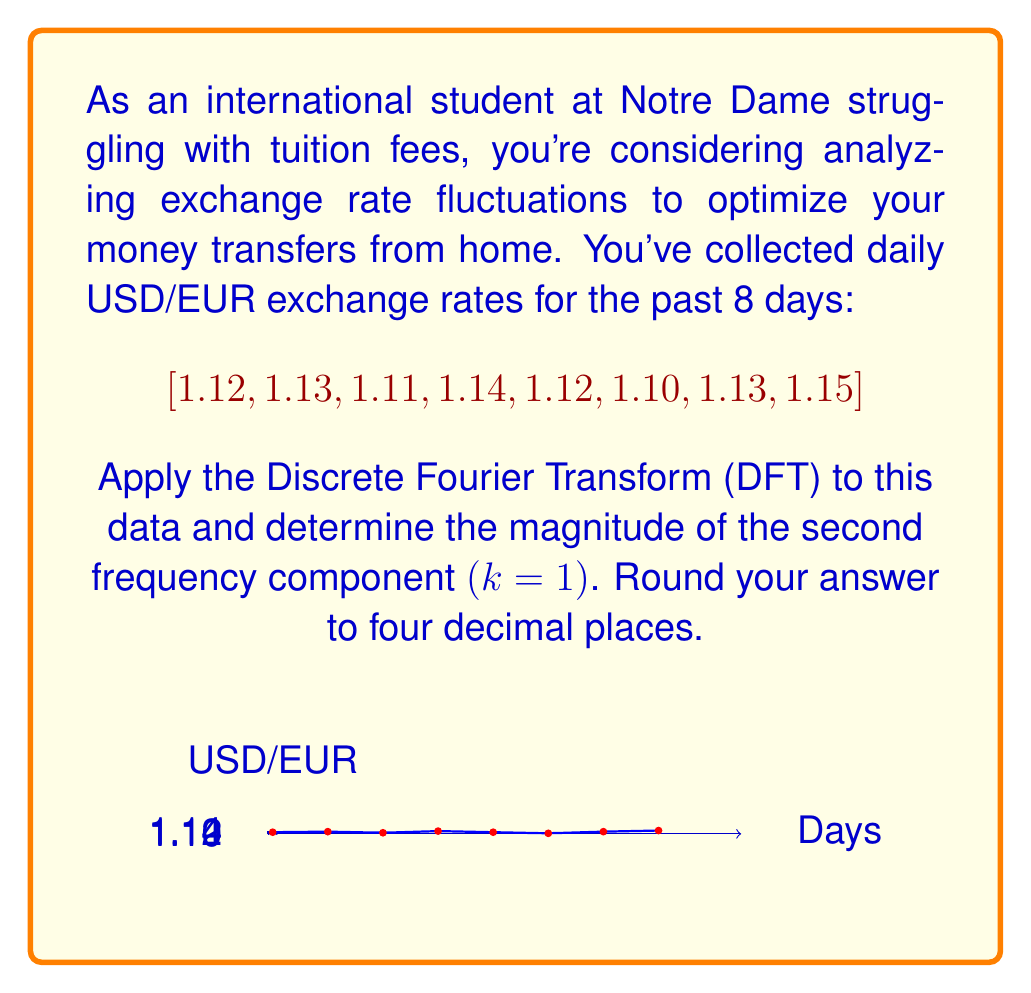What is the answer to this math problem? Let's approach this step-by-step:

1) The Discrete Fourier Transform (DFT) is given by:

   $$X[k] = \sum_{n=0}^{N-1} x[n] e^{-i2\pi kn/N}$$

   where $N$ is the number of samples (8 in this case), $k$ is the frequency index, and $x[n]$ are the input samples.

2) We need to calculate $X[1]$, as we're interested in the second frequency component (k=1):

   $$X[1] = \sum_{n=0}^{7} x[n] e^{-i2\pi n/8}$$

3) Let's expand this:

   $$X[1] = 1.12e^{-i2\pi(0)/8} + 1.13e^{-i2\pi(1)/8} + 1.11e^{-i2\pi(2)/8} + 1.14e^{-i2\pi(3)/8} + 1.12e^{-i2\pi(4)/8} + 1.10e^{-i2\pi(5)/8} + 1.13e^{-i2\pi(6)/8} + 1.15e^{-i2\pi(7)/8}$$

4) Simplify the exponents:

   $$X[1] = 1.12 + 1.13e^{-i\pi/4} + 1.11e^{-i\pi/2} + 1.14e^{-i3\pi/4} + 1.12e^{-i\pi} + 1.10e^{-i5\pi/4} + 1.13e^{-i3\pi/2} + 1.15e^{-i7\pi/4}$$

5) Calculate each term:

   $$X[1] = 1.12 + 1.13(0.7071 - 0.7071i) + 1.11(0 - i) + 1.14(-0.7071 - 0.7071i) + 1.12(-1) + 1.10(-0.7071 + 0.7071i) + 1.13(0 + i) + 1.15(0.7071 + 0.7071i)$$

6) Sum the real and imaginary parts:

   $$X[1] = (1.12 + 0.7991 + 0 - 0.8061 - 1.12 - 0.7778 + 0 + 0.8132) + (-0.7991 - 1.11 - 0.8061 + 0.7778 + 1.13 + 0.8132)i$$
   
   $$X[1] = 0.0484 + 0.0058i$$

7) The magnitude is given by $\sqrt{Re^2 + Im^2}$:

   $$|X[1]| = \sqrt{0.0484^2 + 0.0058^2} = 0.0487$$

8) Rounding to four decimal places:

   $$|X[1]| \approx 0.0487$$
Answer: 0.0487 